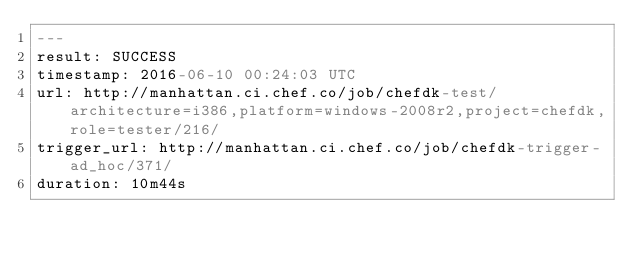Convert code to text. <code><loc_0><loc_0><loc_500><loc_500><_YAML_>---
result: SUCCESS
timestamp: 2016-06-10 00:24:03 UTC
url: http://manhattan.ci.chef.co/job/chefdk-test/architecture=i386,platform=windows-2008r2,project=chefdk,role=tester/216/
trigger_url: http://manhattan.ci.chef.co/job/chefdk-trigger-ad_hoc/371/
duration: 10m44s
</code> 